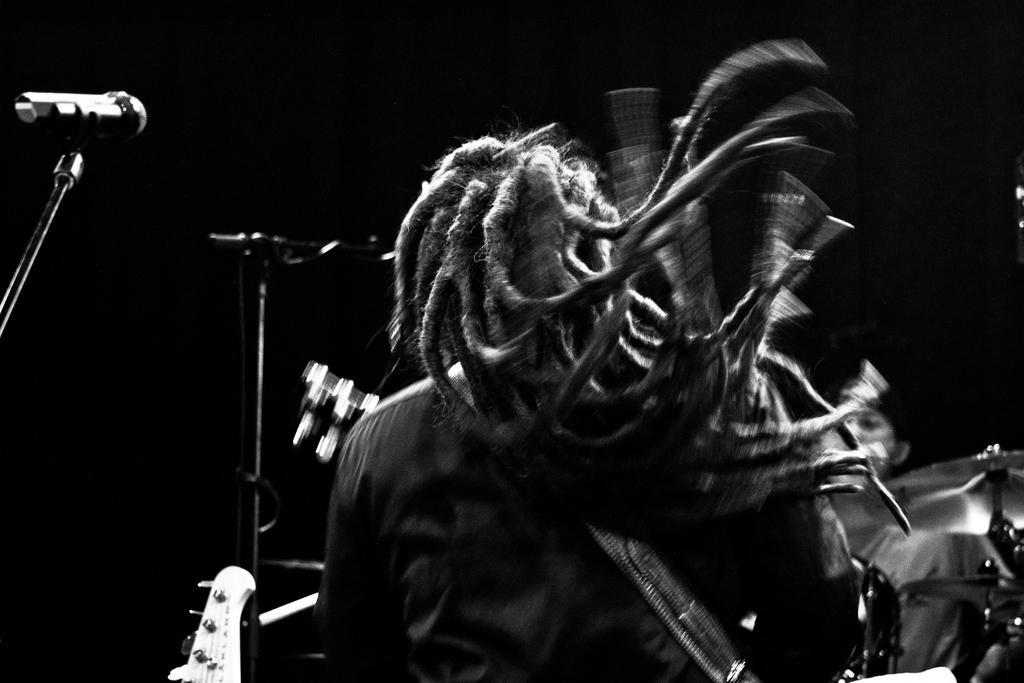How would you summarize this image in a sentence or two? In the center of the image there is a person wearing a guitar. There are mic stands. The background of the image is black in color. 